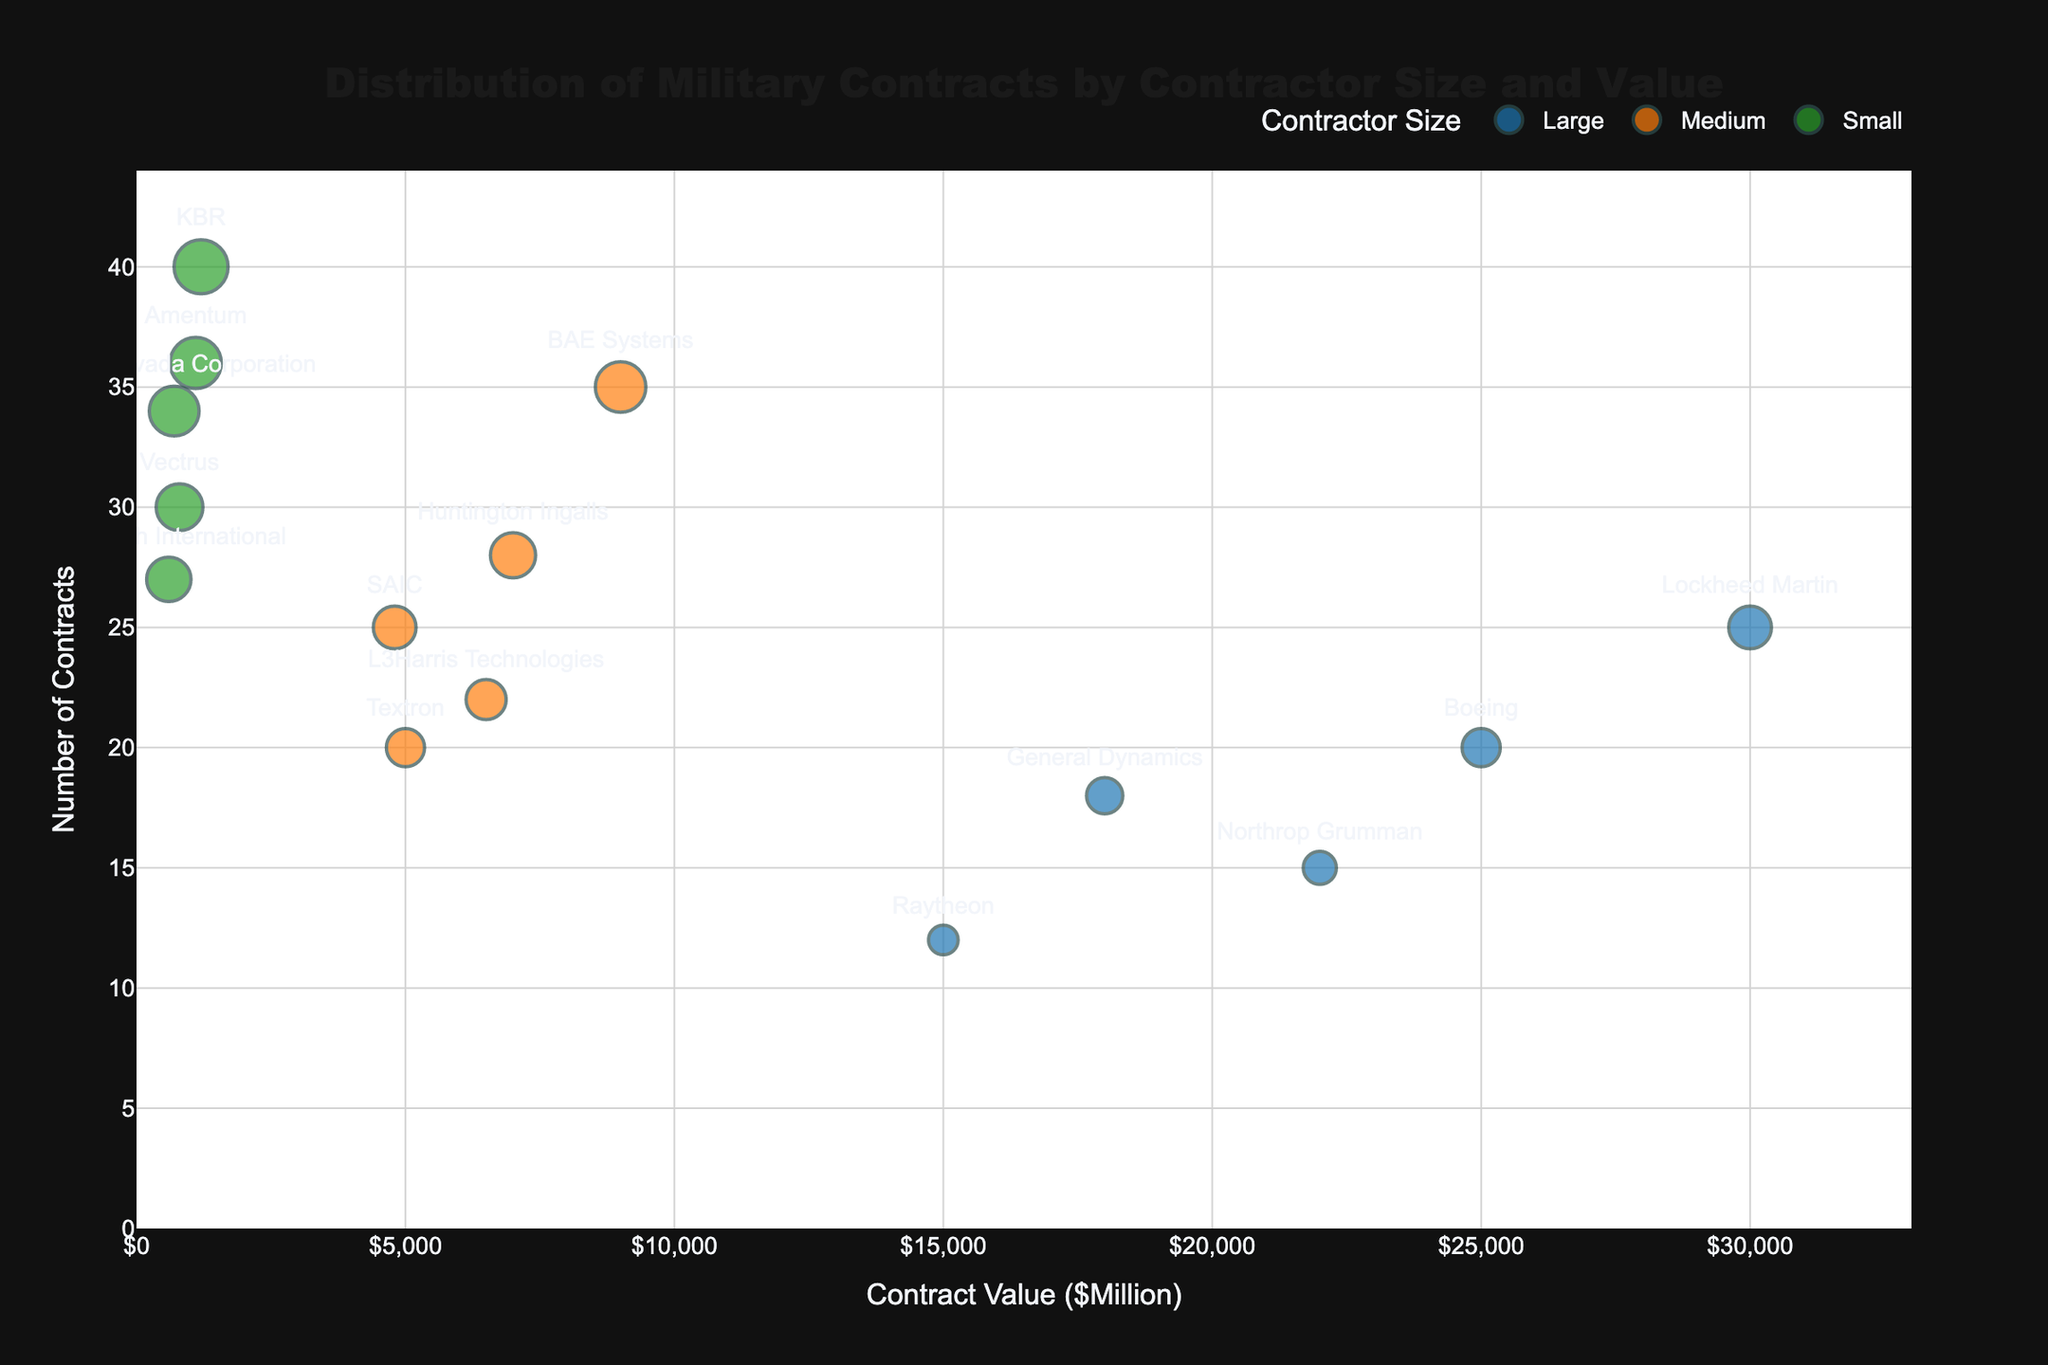What is the title of the figure? The title is located at the top of the figure and reads "Distribution of Military Contracts by Contractor Size and Value."
Answer: Distribution of Military Contracts by Contractor Size and Value How many contractor size categories are represented in the figure, and what are they? By looking at the legend and the different colors representing categories, there are three contractor size categories, which are 'Large', 'Medium', and 'Small'.
Answer: Three (Large, Medium, Small) Which contractor has the highest contract value, and what is that value? By observing the x-axis position of the bubbles and the associated text labels, Lockheed Martin has the highest contract value positioned at $30,000 million.
Answer: Lockheed Martin, $30,000 million Which contractor size category has the most contracts overall? To find this, observe the y-axis values and the size of bubbles in different categories. For the count and sizes, 'Small' contractors such as KBR and Amentum have multiple representatives with a higher number of contracts.
Answer: Small How many contracts does Textron have? Textron is a 'Medium' contractor, and from the figure's y-axis, the bubble for Textron indicates 20 contracts.
Answer: 20 What is the combined contract value of all 'Medium' contractors? Sum the contract values of all 'Medium' contractors by looking at the x-axis values: BAE Systems (9000) + Huntington Ingalls (7000) + L3Harris Technologies (6500) + Textron (5000) + SAIC (4800) = 37,300 million.
Answer: 37,300 million Which 'Large' contractor has the lowest number of contracts, and how many does it have? From observing the y-axis values for the 'Large' category, Raytheon has the lowest number of contracts with 12.
Answer: Raytheon, 12 Compare the number of contracts between Lockheed Martin and KBR. Who has more and by how much? Lockheed Martin has 25 contracts and KBR has 40. To find the difference, subtract 25 from 40. KBR has 15 more contracts than Lockheed Martin.
Answer: KBR, 15 Which 'Small' contractor has the highest contract value, and what is the value? Among the 'Small' contractors depicted on the x-axis, KBR has the highest contract value positioned at $1200 million.
Answer: KBR, $1200 million Is there any contractor with more than 30 contracts in the 'Large' category? By looking at the y-axis values in the 'Large' category, none of the contractors have more than 30 contracts.
Answer: No 